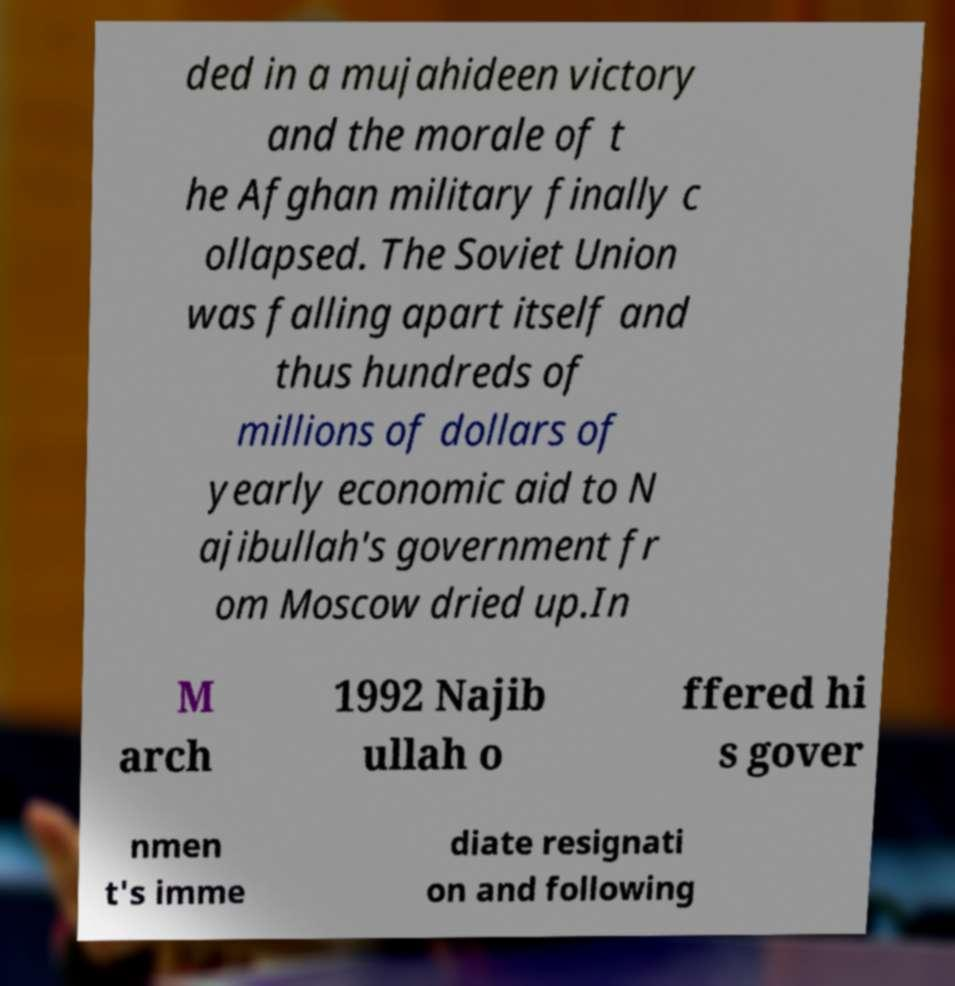There's text embedded in this image that I need extracted. Can you transcribe it verbatim? ded in a mujahideen victory and the morale of t he Afghan military finally c ollapsed. The Soviet Union was falling apart itself and thus hundreds of millions of dollars of yearly economic aid to N ajibullah's government fr om Moscow dried up.In M arch 1992 Najib ullah o ffered hi s gover nmen t's imme diate resignati on and following 